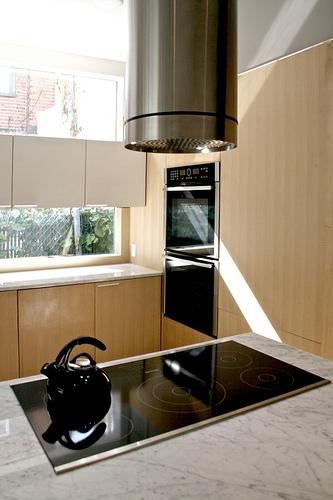What time of day is it in this picture?
Answer briefly. Afternoon. Is there a red kettle on the stove?
Be succinct. No. How many burners does the range have?
Answer briefly. 5. 